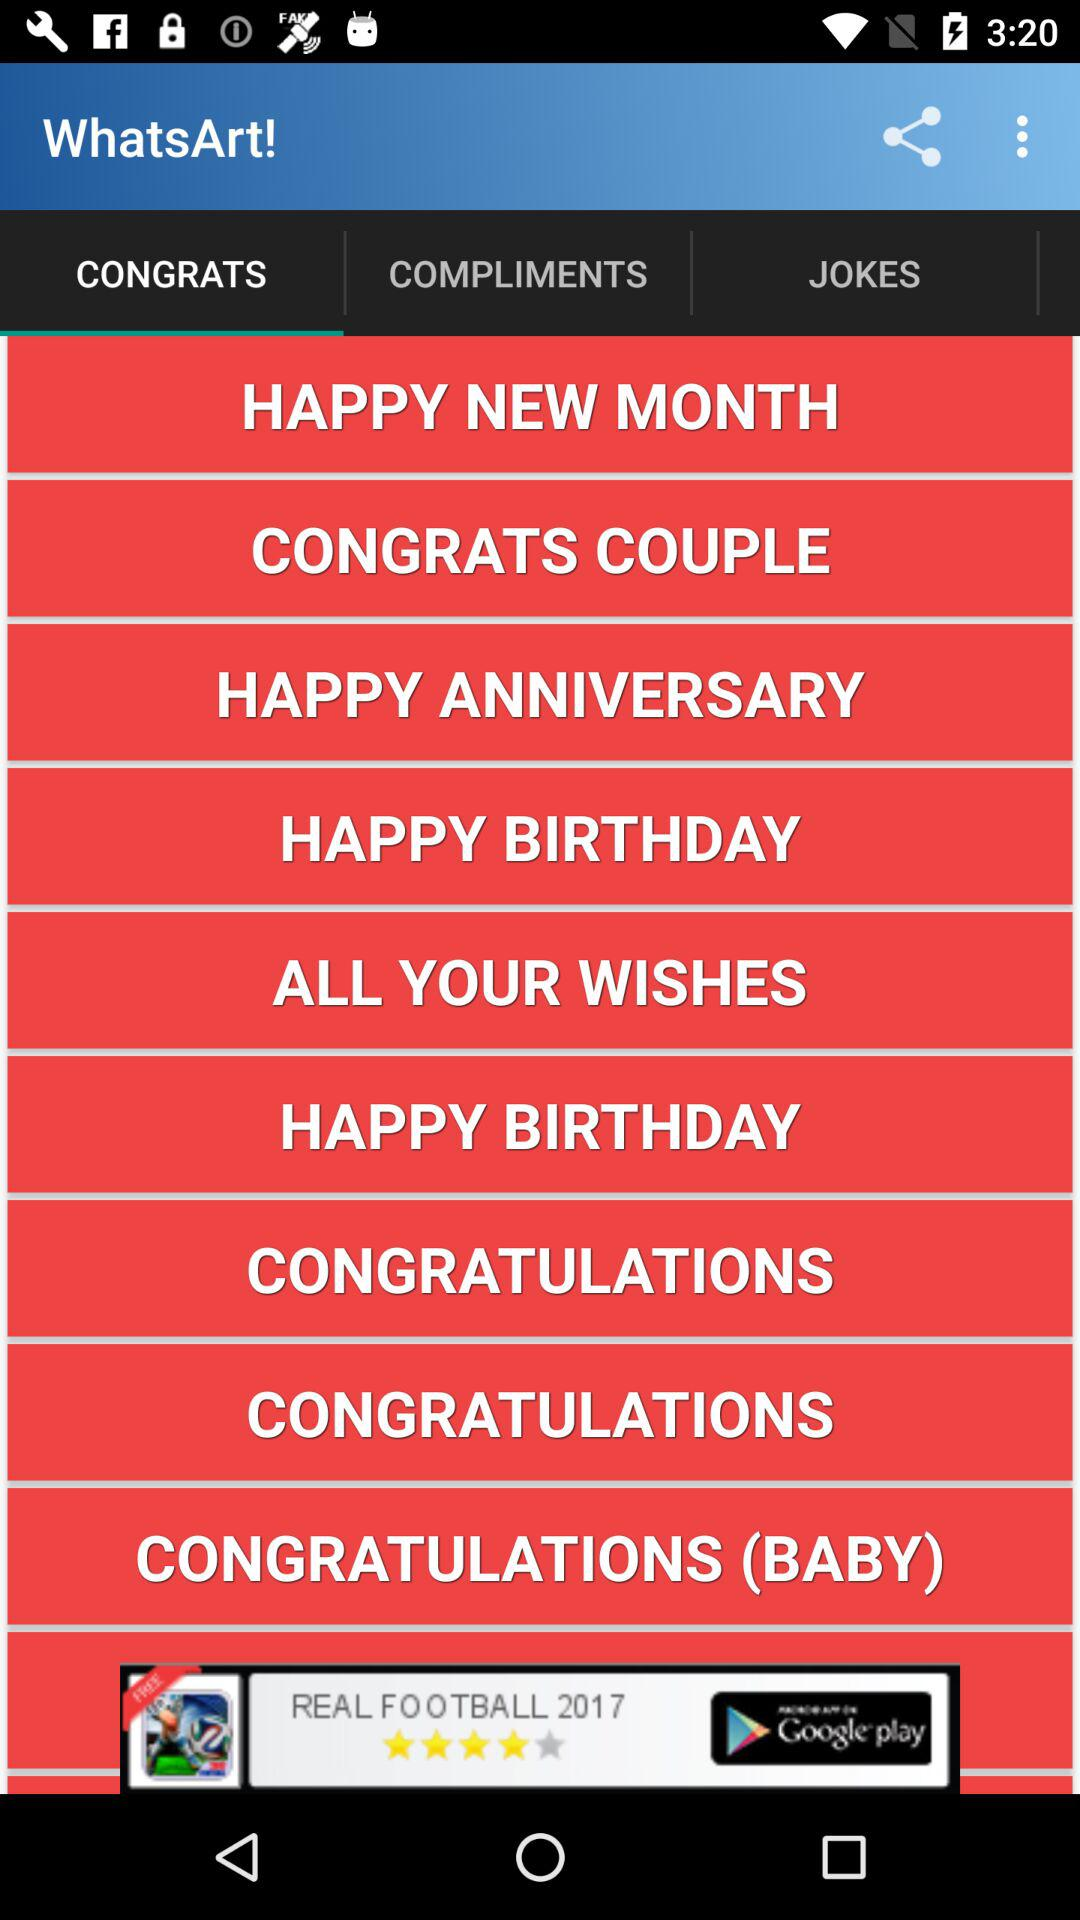Which tab is selected? The selected tab is "CONGRATS". 